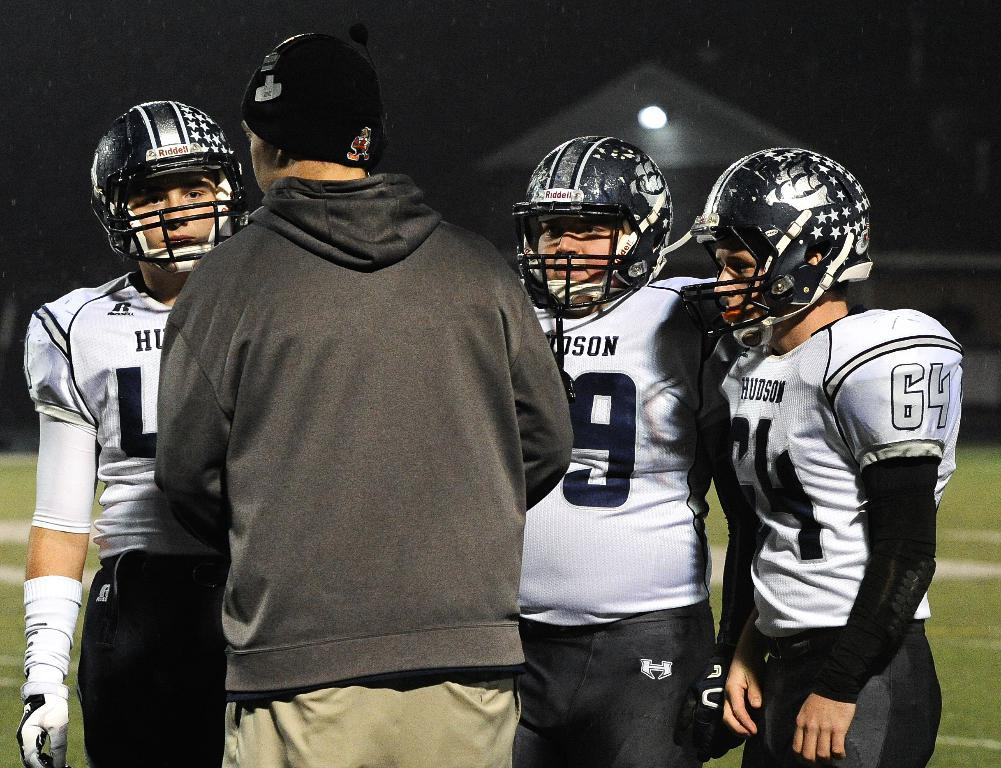How many people are in the image? There are four people in the image. What are the three people wearing helmets also wearing? The three people wearing helmets are also wearing white color t-shirts. What type of surface is visible in the image? There is grass visible in the image. Can you describe the lighting in the image? There is light in the image, but it is slightly dark. What scent can be detected in the image? There is no information about a scent in the image, so it cannot be determined. --- Facts: 1. There is a car in the image. 2. The car is red. 3. The car has four wheels. 4. There is a road in the image. 5. The road is paved. 6. There are trees in the background of the image. Absurd Topics: dance, ocean, bird Conversation: What type of vehicle is in the image? There is a car in the image. What color is the car? The car is red. How many wheels does the car have? The car has four wheels. What type of surface is visible in the image? There is a road in the image. What is the condition of the road? The road is paved. What can be seen in the background of the image? There are trees in the background of the image. Reasoning: Let's think step by step in order to produce the conversation. We start by identifying the main subject in the image, which is the car. Then, we describe the car's color and number of wheels. Next, we mention the type of surface visible in the image, which is a road. We then describe the condition of the road, noting that it is paved. Finally, we describe the background of the image, which includes trees. Absurd Question/Answer: Can you see any birds dancing in the ocean in the image? There is no ocean or birds present in the image, so this scenario cannot be observed. 